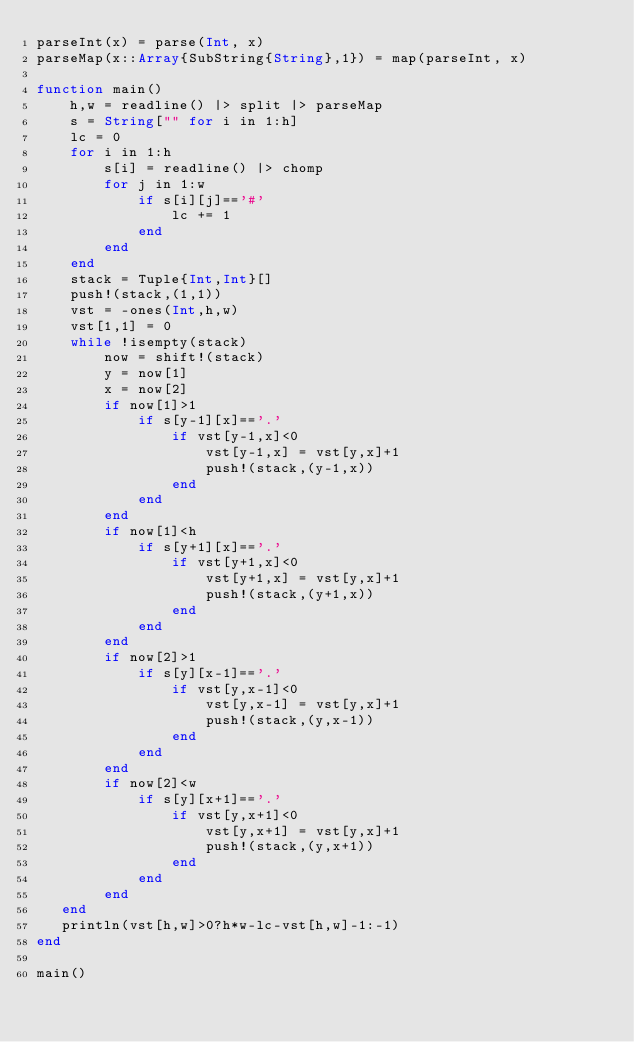<code> <loc_0><loc_0><loc_500><loc_500><_Julia_>parseInt(x) = parse(Int, x)
parseMap(x::Array{SubString{String},1}) = map(parseInt, x)

function main()
    h,w = readline() |> split |> parseMap
    s = String["" for i in 1:h]
    lc = 0
    for i in 1:h
        s[i] = readline() |> chomp
        for j in 1:w
            if s[i][j]=='#'
                lc += 1
            end
        end
    end
    stack = Tuple{Int,Int}[]
    push!(stack,(1,1))
    vst = -ones(Int,h,w)
    vst[1,1] = 0
    while !isempty(stack)
        now = shift!(stack)
        y = now[1]
        x = now[2]
        if now[1]>1
            if s[y-1][x]=='.'
                if vst[y-1,x]<0
                    vst[y-1,x] = vst[y,x]+1
                    push!(stack,(y-1,x))
                end
            end
        end
        if now[1]<h
            if s[y+1][x]=='.'
                if vst[y+1,x]<0
                    vst[y+1,x] = vst[y,x]+1
                    push!(stack,(y+1,x))
                end
            end
        end
        if now[2]>1
            if s[y][x-1]=='.'
                if vst[y,x-1]<0
                    vst[y,x-1] = vst[y,x]+1
                    push!(stack,(y,x-1))
                end
            end
        end
        if now[2]<w
            if s[y][x+1]=='.'
                if vst[y,x+1]<0
                    vst[y,x+1] = vst[y,x]+1
                    push!(stack,(y,x+1))
                end
            end
        end
   end
   println(vst[h,w]>0?h*w-lc-vst[h,w]-1:-1)
end

main()</code> 